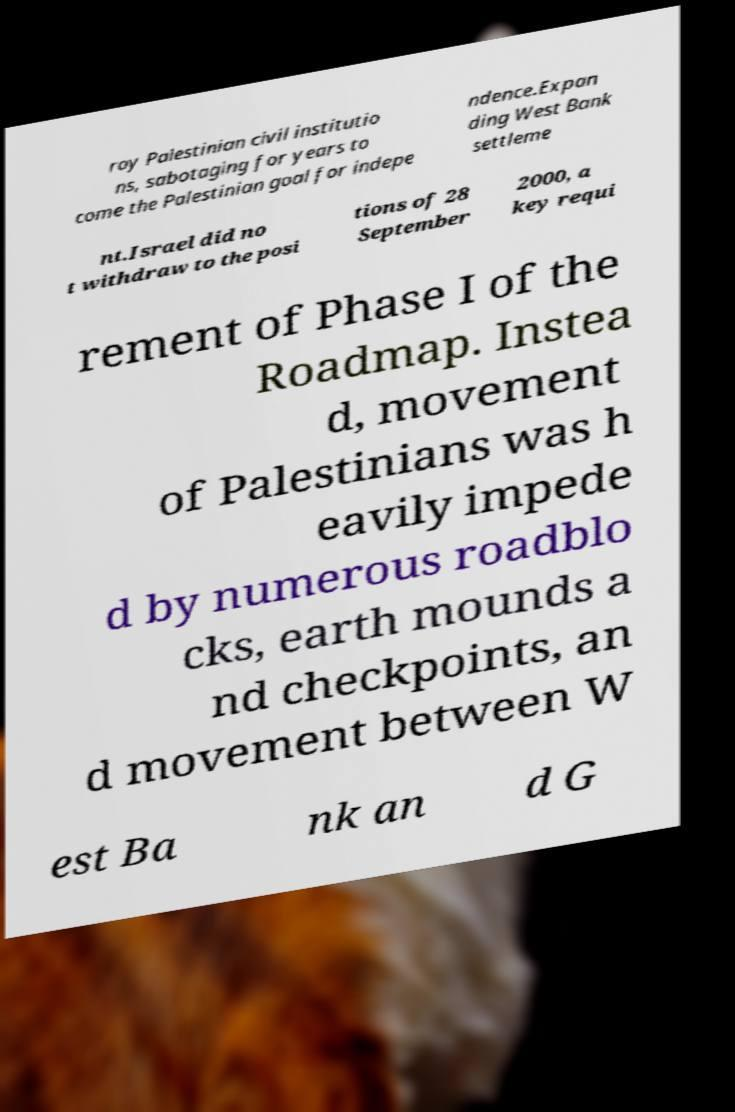I need the written content from this picture converted into text. Can you do that? roy Palestinian civil institutio ns, sabotaging for years to come the Palestinian goal for indepe ndence.Expan ding West Bank settleme nt.Israel did no t withdraw to the posi tions of 28 September 2000, a key requi rement of Phase I of the Roadmap. Instea d, movement of Palestinians was h eavily impede d by numerous roadblo cks, earth mounds a nd checkpoints, an d movement between W est Ba nk an d G 